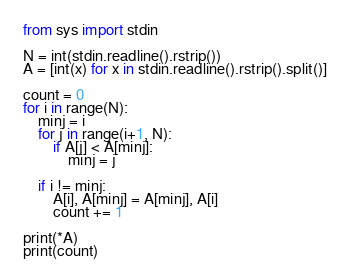Convert code to text. <code><loc_0><loc_0><loc_500><loc_500><_Python_>from sys import stdin

N = int(stdin.readline().rstrip())
A = [int(x) for x in stdin.readline().rstrip().split()]

count = 0
for i in range(N):
    minj = i
    for j in range(i+1, N):
        if A[j] < A[minj]:
            minj = j

    if i != minj:
        A[i], A[minj] = A[minj], A[i]
        count += 1

print(*A)
print(count)
</code> 